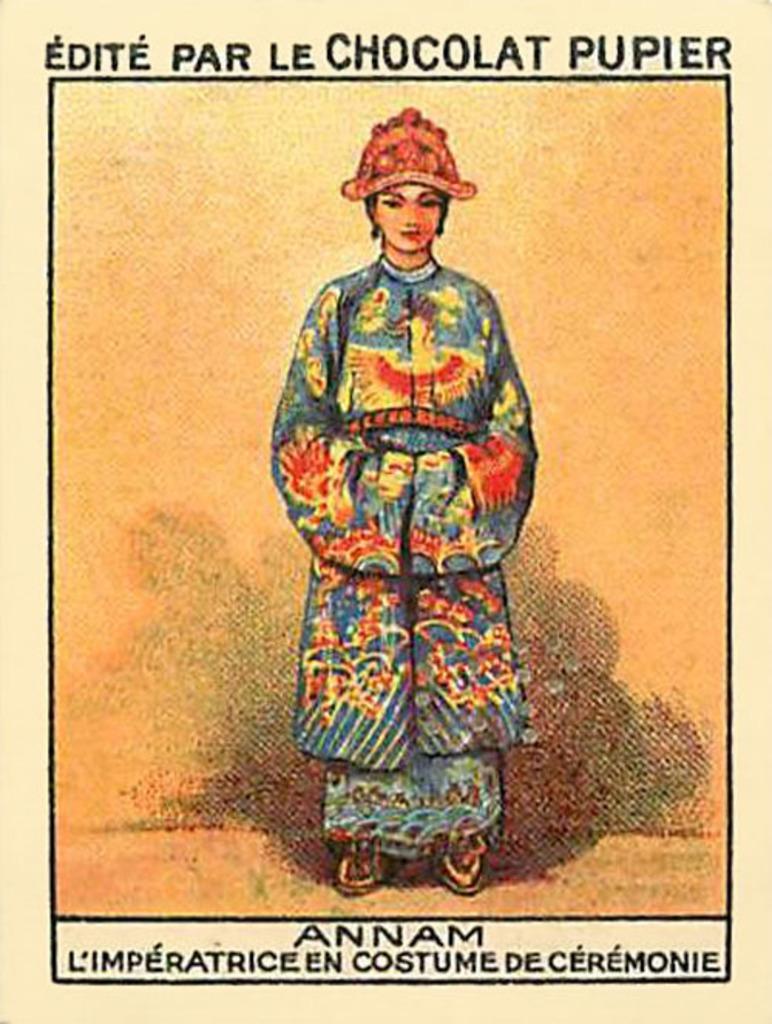Could you give a brief overview of what you see in this image? This image consists of a poster. In which we can see a person's along with the text. 